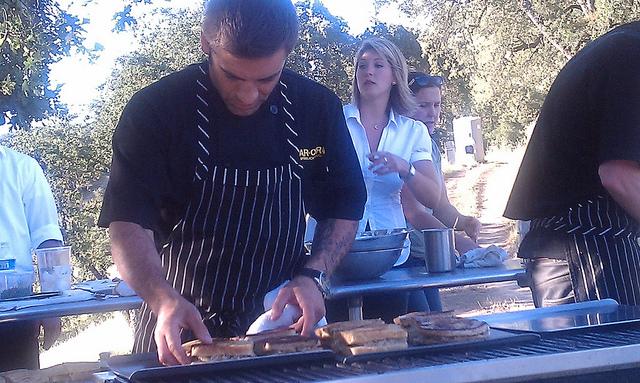What is the man making?
Quick response, please. Sandwiches. Is the man torturing the food by cooking it?
Be succinct. No. Is this a cooking competition?
Quick response, please. Yes. 